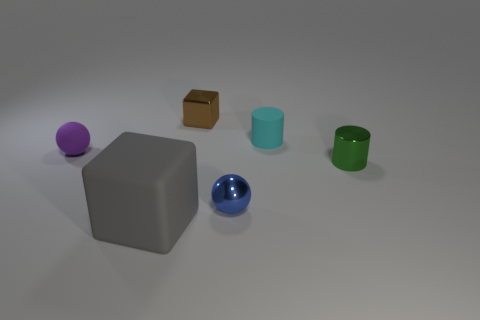What shape is the green thing that is the same size as the purple rubber object?
Give a very brief answer. Cylinder. Is there anything else that is the same size as the blue object?
Ensure brevity in your answer.  Yes. Is the size of the ball that is to the left of the brown shiny block the same as the sphere to the right of the purple matte thing?
Offer a terse response. Yes. How big is the cube behind the rubber cylinder?
Provide a short and direct response. Small. What color is the rubber sphere that is the same size as the blue shiny ball?
Keep it short and to the point. Purple. Is the size of the matte cylinder the same as the purple object?
Provide a short and direct response. Yes. There is a metal object that is both left of the small green object and behind the small blue shiny sphere; how big is it?
Give a very brief answer. Small. How many shiny things are big objects or big red things?
Give a very brief answer. 0. Are there more brown things to the left of the brown metallic block than tiny matte cylinders?
Keep it short and to the point. No. There is a block that is to the right of the big rubber object; what is it made of?
Your response must be concise. Metal. 